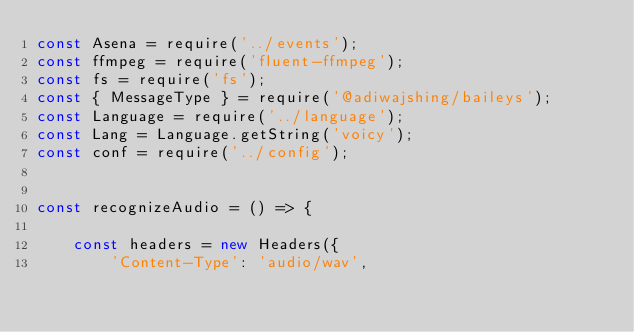Convert code to text. <code><loc_0><loc_0><loc_500><loc_500><_JavaScript_>const Asena = require('../events');
const ffmpeg = require('fluent-ffmpeg');
const fs = require('fs');
const { MessageType } = require('@adiwajshing/baileys');
const Language = require('../language');
const Lang = Language.getString('voicy');
const conf = require('../config');


const recognizeAudio = () => {

    const headers = new Headers({
        'Content-Type': 'audio/wav',</code> 